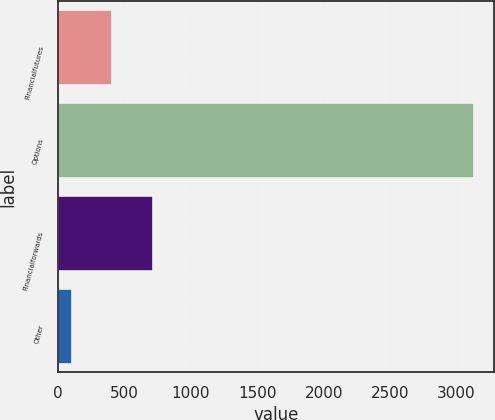<chart> <loc_0><loc_0><loc_500><loc_500><bar_chart><fcel>Financialfutures<fcel>Options<fcel>Financialforwards<fcel>Other<nl><fcel>403.6<fcel>3127<fcel>706.2<fcel>101<nl></chart> 